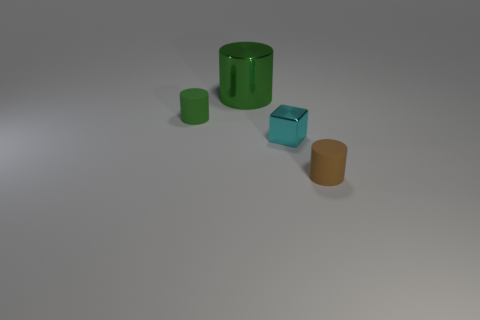Subtract all tiny brown cylinders. How many cylinders are left? 2 Add 3 tiny cyan objects. How many objects exist? 7 Subtract all green cylinders. How many cylinders are left? 1 Subtract all blocks. How many objects are left? 3 Subtract 1 cylinders. How many cylinders are left? 2 Subtract all cyan things. Subtract all tiny green matte objects. How many objects are left? 2 Add 3 small green cylinders. How many small green cylinders are left? 4 Add 3 large yellow rubber things. How many large yellow rubber things exist? 3 Subtract 0 purple cubes. How many objects are left? 4 Subtract all cyan cylinders. Subtract all blue blocks. How many cylinders are left? 3 